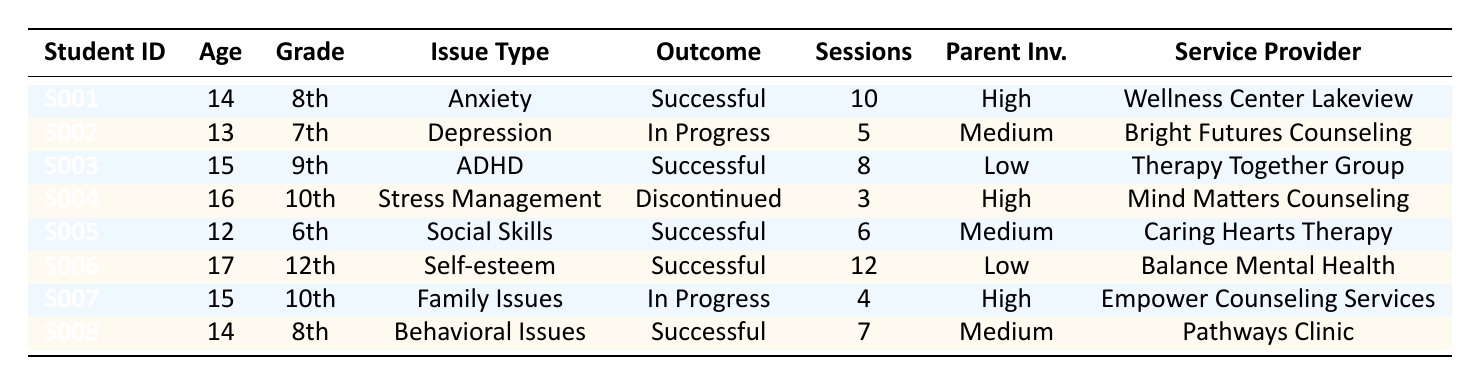What is the total number of successful referrals? By reviewing the table, we can identify each referral outcome. The successful referrals are S001, S003, S005, S006, and S008. There are 5 successful referrals in total.
Answer: 5 How many students are receiving ongoing services? The ongoing services are indicated by the outcome "in progress." Referrals S002 and S007 have this outcome. Therefore, there are 2 students receiving ongoing services.
Answer: 2 Which service provider had the most referrals? To determine the provider with the most referrals, we look at the service provider column. Each provider is mentioned as follows: Wellness Center Lakeview (1), Bright Futures Counseling (1), Therapy Together Group (1), Mind Matters Counseling (1), Caring Hearts Therapy (1), Balance Mental Health (1), Empower Counseling Services (1), and Pathways Clinic (1). All providers had only 1 referral each, so none had more than others.
Answer: None What is the average number of sessions for successful outcomes? For successful outcomes, the session counts are: S001 (10), S003 (8), S005 (6), S006 (12), and S008 (7). Adding these gives 10 + 8 + 6 + 12 + 7 = 43 sessions. Then, we divide by the number of successful outcomes, which is 5. Therefore, 43/5 = 8.6.
Answer: 8.6 Is there any referral that was discontinued? Referring to the outcome column, we find S004 has the outcome of "discontinued." This indicates that at least one referral was discontinued.
Answer: Yes How does parental involvement correlate with the outcomes of referrals? Looking at the table, successful outcomes have both high (S001, S005) and low (S003, S006) parental involvement, while ongoing outcomes (S002, S007) include medium and high involvement. Discontinued has high involvement (S004). Thus, there is no clear correlation between parental involvement levels and outcomes.
Answer: No clear correlation What percentage of students had high parent involvement? Here, we identify the students with high parent involvement: S001, S004, and S007 (3 out of 8 total students). To find the percentage: (3/8) * 100 = 37.5%.
Answer: 37.5% Which grade had the highest number of successful referrals? Looking through successful referrals: 8th grade has S001 and S008, 9th has S003, and 6th has S005. Thus, 8th grade has the most successful referrals (2).
Answer: 8th grade Did any student receive services from more than one service provider? Reviewing the table shows that each student has been referred to only one service provider. Thus, no student has received services from more than one provider.
Answer: No What was the most common issue type for successful referrals? Analyzing successful referrals: S001 (anxiety), S003 (ADHD), S005 (social skills), S006 (self-esteem), S008 (behavioral issues). Each successful referral represents different issues, hence no common issue type exists among them.
Answer: None 